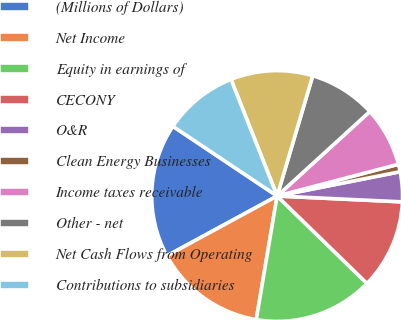Convert chart to OTSL. <chart><loc_0><loc_0><loc_500><loc_500><pie_chart><fcel>(Millions of Dollars)<fcel>Net Income<fcel>Equity in earnings of<fcel>CECONY<fcel>O&R<fcel>Clean Energy Businesses<fcel>Income taxes receivable<fcel>Other - net<fcel>Net Cash Flows from Operating<fcel>Contributions to subsidiaries<nl><fcel>17.3%<fcel>14.42%<fcel>15.38%<fcel>11.54%<fcel>3.85%<fcel>0.97%<fcel>7.69%<fcel>8.66%<fcel>10.58%<fcel>9.62%<nl></chart> 